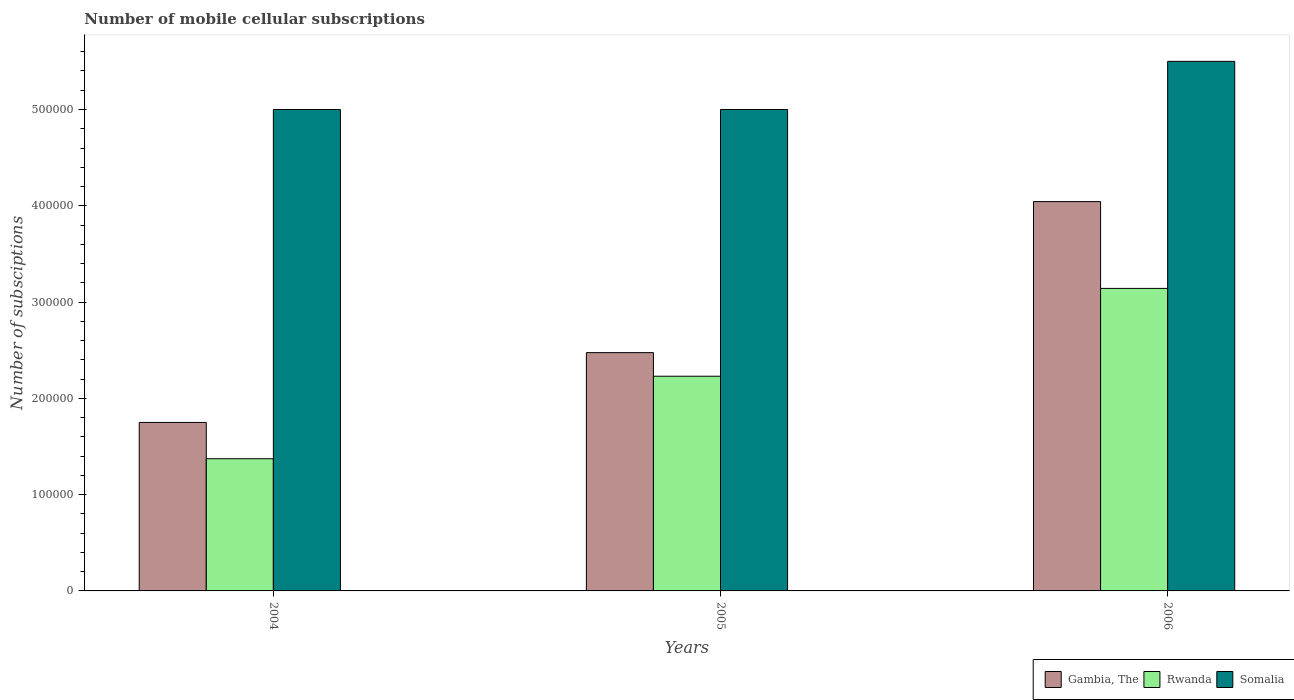How many different coloured bars are there?
Your answer should be very brief. 3. How many groups of bars are there?
Offer a very short reply. 3. Are the number of bars per tick equal to the number of legend labels?
Make the answer very short. Yes. How many bars are there on the 3rd tick from the right?
Give a very brief answer. 3. What is the label of the 2nd group of bars from the left?
Ensure brevity in your answer.  2005. In how many cases, is the number of bars for a given year not equal to the number of legend labels?
Your response must be concise. 0. What is the number of mobile cellular subscriptions in Rwanda in 2004?
Your response must be concise. 1.37e+05. Across all years, what is the maximum number of mobile cellular subscriptions in Rwanda?
Offer a very short reply. 3.14e+05. Across all years, what is the minimum number of mobile cellular subscriptions in Somalia?
Your answer should be very brief. 5.00e+05. In which year was the number of mobile cellular subscriptions in Gambia, The minimum?
Your answer should be compact. 2004. What is the total number of mobile cellular subscriptions in Gambia, The in the graph?
Provide a succinct answer. 8.27e+05. What is the difference between the number of mobile cellular subscriptions in Rwanda in 2005 and the number of mobile cellular subscriptions in Somalia in 2004?
Keep it short and to the point. -2.77e+05. What is the average number of mobile cellular subscriptions in Gambia, The per year?
Offer a terse response. 2.76e+05. In the year 2004, what is the difference between the number of mobile cellular subscriptions in Gambia, The and number of mobile cellular subscriptions in Somalia?
Your answer should be compact. -3.25e+05. In how many years, is the number of mobile cellular subscriptions in Somalia greater than 500000?
Keep it short and to the point. 1. What is the ratio of the number of mobile cellular subscriptions in Rwanda in 2005 to that in 2006?
Make the answer very short. 0.71. What is the difference between the highest and the second highest number of mobile cellular subscriptions in Rwanda?
Your answer should be very brief. 9.12e+04. What is the difference between the highest and the lowest number of mobile cellular subscriptions in Rwanda?
Make the answer very short. 1.77e+05. What does the 2nd bar from the left in 2005 represents?
Make the answer very short. Rwanda. What does the 3rd bar from the right in 2004 represents?
Offer a terse response. Gambia, The. Are all the bars in the graph horizontal?
Offer a terse response. No. How many years are there in the graph?
Your response must be concise. 3. Are the values on the major ticks of Y-axis written in scientific E-notation?
Offer a terse response. No. Does the graph contain any zero values?
Provide a succinct answer. No. Does the graph contain grids?
Your answer should be very brief. No. How many legend labels are there?
Ensure brevity in your answer.  3. How are the legend labels stacked?
Your answer should be very brief. Horizontal. What is the title of the graph?
Keep it short and to the point. Number of mobile cellular subscriptions. Does "Kazakhstan" appear as one of the legend labels in the graph?
Provide a short and direct response. No. What is the label or title of the Y-axis?
Make the answer very short. Number of subsciptions. What is the Number of subsciptions in Gambia, The in 2004?
Your answer should be compact. 1.75e+05. What is the Number of subsciptions in Rwanda in 2004?
Your answer should be very brief. 1.37e+05. What is the Number of subsciptions of Gambia, The in 2005?
Offer a very short reply. 2.47e+05. What is the Number of subsciptions of Rwanda in 2005?
Your answer should be very brief. 2.23e+05. What is the Number of subsciptions in Somalia in 2005?
Offer a terse response. 5.00e+05. What is the Number of subsciptions in Gambia, The in 2006?
Your answer should be very brief. 4.04e+05. What is the Number of subsciptions in Rwanda in 2006?
Make the answer very short. 3.14e+05. What is the Number of subsciptions in Somalia in 2006?
Your response must be concise. 5.50e+05. Across all years, what is the maximum Number of subsciptions of Gambia, The?
Keep it short and to the point. 4.04e+05. Across all years, what is the maximum Number of subsciptions in Rwanda?
Ensure brevity in your answer.  3.14e+05. Across all years, what is the maximum Number of subsciptions in Somalia?
Make the answer very short. 5.50e+05. Across all years, what is the minimum Number of subsciptions of Gambia, The?
Offer a terse response. 1.75e+05. Across all years, what is the minimum Number of subsciptions of Rwanda?
Your response must be concise. 1.37e+05. Across all years, what is the minimum Number of subsciptions of Somalia?
Your response must be concise. 5.00e+05. What is the total Number of subsciptions in Gambia, The in the graph?
Give a very brief answer. 8.27e+05. What is the total Number of subsciptions of Rwanda in the graph?
Your answer should be very brief. 6.74e+05. What is the total Number of subsciptions of Somalia in the graph?
Make the answer very short. 1.55e+06. What is the difference between the Number of subsciptions in Gambia, The in 2004 and that in 2005?
Offer a very short reply. -7.25e+04. What is the difference between the Number of subsciptions in Rwanda in 2004 and that in 2005?
Your response must be concise. -8.57e+04. What is the difference between the Number of subsciptions of Somalia in 2004 and that in 2005?
Your answer should be compact. 0. What is the difference between the Number of subsciptions of Gambia, The in 2004 and that in 2006?
Keep it short and to the point. -2.29e+05. What is the difference between the Number of subsciptions of Rwanda in 2004 and that in 2006?
Provide a succinct answer. -1.77e+05. What is the difference between the Number of subsciptions in Gambia, The in 2005 and that in 2006?
Your answer should be compact. -1.57e+05. What is the difference between the Number of subsciptions of Rwanda in 2005 and that in 2006?
Provide a short and direct response. -9.12e+04. What is the difference between the Number of subsciptions in Somalia in 2005 and that in 2006?
Make the answer very short. -5.00e+04. What is the difference between the Number of subsciptions in Gambia, The in 2004 and the Number of subsciptions in Rwanda in 2005?
Ensure brevity in your answer.  -4.80e+04. What is the difference between the Number of subsciptions of Gambia, The in 2004 and the Number of subsciptions of Somalia in 2005?
Provide a short and direct response. -3.25e+05. What is the difference between the Number of subsciptions in Rwanda in 2004 and the Number of subsciptions in Somalia in 2005?
Your response must be concise. -3.63e+05. What is the difference between the Number of subsciptions of Gambia, The in 2004 and the Number of subsciptions of Rwanda in 2006?
Provide a succinct answer. -1.39e+05. What is the difference between the Number of subsciptions of Gambia, The in 2004 and the Number of subsciptions of Somalia in 2006?
Give a very brief answer. -3.75e+05. What is the difference between the Number of subsciptions in Rwanda in 2004 and the Number of subsciptions in Somalia in 2006?
Provide a short and direct response. -4.13e+05. What is the difference between the Number of subsciptions of Gambia, The in 2005 and the Number of subsciptions of Rwanda in 2006?
Ensure brevity in your answer.  -6.67e+04. What is the difference between the Number of subsciptions of Gambia, The in 2005 and the Number of subsciptions of Somalia in 2006?
Offer a very short reply. -3.03e+05. What is the difference between the Number of subsciptions of Rwanda in 2005 and the Number of subsciptions of Somalia in 2006?
Your answer should be very brief. -3.27e+05. What is the average Number of subsciptions in Gambia, The per year?
Your answer should be very brief. 2.76e+05. What is the average Number of subsciptions in Rwanda per year?
Your answer should be very brief. 2.25e+05. What is the average Number of subsciptions of Somalia per year?
Offer a terse response. 5.17e+05. In the year 2004, what is the difference between the Number of subsciptions in Gambia, The and Number of subsciptions in Rwanda?
Give a very brief answer. 3.77e+04. In the year 2004, what is the difference between the Number of subsciptions in Gambia, The and Number of subsciptions in Somalia?
Your response must be concise. -3.25e+05. In the year 2004, what is the difference between the Number of subsciptions in Rwanda and Number of subsciptions in Somalia?
Your answer should be very brief. -3.63e+05. In the year 2005, what is the difference between the Number of subsciptions of Gambia, The and Number of subsciptions of Rwanda?
Provide a short and direct response. 2.45e+04. In the year 2005, what is the difference between the Number of subsciptions in Gambia, The and Number of subsciptions in Somalia?
Give a very brief answer. -2.53e+05. In the year 2005, what is the difference between the Number of subsciptions in Rwanda and Number of subsciptions in Somalia?
Your answer should be compact. -2.77e+05. In the year 2006, what is the difference between the Number of subsciptions in Gambia, The and Number of subsciptions in Rwanda?
Offer a very short reply. 9.01e+04. In the year 2006, what is the difference between the Number of subsciptions in Gambia, The and Number of subsciptions in Somalia?
Your answer should be compact. -1.46e+05. In the year 2006, what is the difference between the Number of subsciptions in Rwanda and Number of subsciptions in Somalia?
Your response must be concise. -2.36e+05. What is the ratio of the Number of subsciptions of Gambia, The in 2004 to that in 2005?
Your response must be concise. 0.71. What is the ratio of the Number of subsciptions of Rwanda in 2004 to that in 2005?
Provide a short and direct response. 0.62. What is the ratio of the Number of subsciptions in Somalia in 2004 to that in 2005?
Make the answer very short. 1. What is the ratio of the Number of subsciptions of Gambia, The in 2004 to that in 2006?
Your answer should be compact. 0.43. What is the ratio of the Number of subsciptions in Rwanda in 2004 to that in 2006?
Your answer should be very brief. 0.44. What is the ratio of the Number of subsciptions in Somalia in 2004 to that in 2006?
Your response must be concise. 0.91. What is the ratio of the Number of subsciptions of Gambia, The in 2005 to that in 2006?
Your answer should be very brief. 0.61. What is the ratio of the Number of subsciptions of Rwanda in 2005 to that in 2006?
Ensure brevity in your answer.  0.71. What is the difference between the highest and the second highest Number of subsciptions of Gambia, The?
Ensure brevity in your answer.  1.57e+05. What is the difference between the highest and the second highest Number of subsciptions of Rwanda?
Give a very brief answer. 9.12e+04. What is the difference between the highest and the second highest Number of subsciptions of Somalia?
Provide a succinct answer. 5.00e+04. What is the difference between the highest and the lowest Number of subsciptions of Gambia, The?
Make the answer very short. 2.29e+05. What is the difference between the highest and the lowest Number of subsciptions in Rwanda?
Your answer should be very brief. 1.77e+05. What is the difference between the highest and the lowest Number of subsciptions of Somalia?
Your response must be concise. 5.00e+04. 